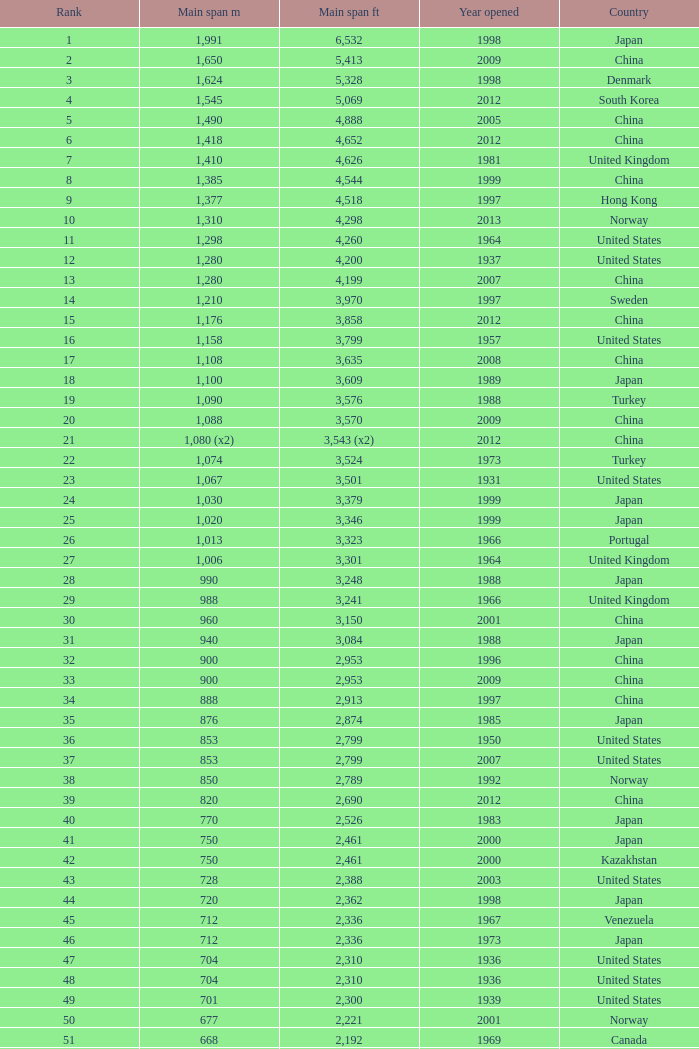What is the main span feet from opening year of 1936 in the United States with a rank greater than 47 and 421 main span metres? 1381.0. 